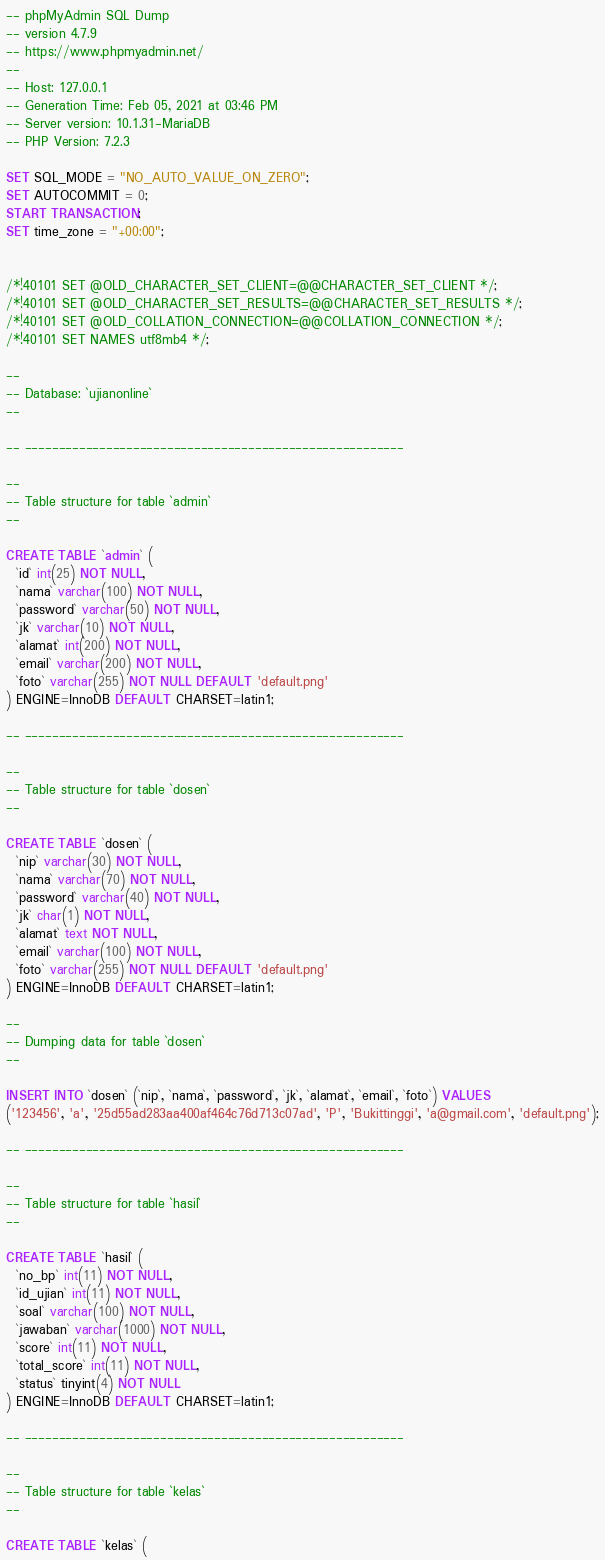Convert code to text. <code><loc_0><loc_0><loc_500><loc_500><_SQL_>-- phpMyAdmin SQL Dump
-- version 4.7.9
-- https://www.phpmyadmin.net/
--
-- Host: 127.0.0.1
-- Generation Time: Feb 05, 2021 at 03:46 PM
-- Server version: 10.1.31-MariaDB
-- PHP Version: 7.2.3

SET SQL_MODE = "NO_AUTO_VALUE_ON_ZERO";
SET AUTOCOMMIT = 0;
START TRANSACTION;
SET time_zone = "+00:00";


/*!40101 SET @OLD_CHARACTER_SET_CLIENT=@@CHARACTER_SET_CLIENT */;
/*!40101 SET @OLD_CHARACTER_SET_RESULTS=@@CHARACTER_SET_RESULTS */;
/*!40101 SET @OLD_COLLATION_CONNECTION=@@COLLATION_CONNECTION */;
/*!40101 SET NAMES utf8mb4 */;

--
-- Database: `ujianonline`
--

-- --------------------------------------------------------

--
-- Table structure for table `admin`
--

CREATE TABLE `admin` (
  `id` int(25) NOT NULL,
  `nama` varchar(100) NOT NULL,
  `password` varchar(50) NOT NULL,
  `jk` varchar(10) NOT NULL,
  `alamat` int(200) NOT NULL,
  `email` varchar(200) NOT NULL,
  `foto` varchar(255) NOT NULL DEFAULT 'default.png'
) ENGINE=InnoDB DEFAULT CHARSET=latin1;

-- --------------------------------------------------------

--
-- Table structure for table `dosen`
--

CREATE TABLE `dosen` (
  `nip` varchar(30) NOT NULL,
  `nama` varchar(70) NOT NULL,
  `password` varchar(40) NOT NULL,
  `jk` char(1) NOT NULL,
  `alamat` text NOT NULL,
  `email` varchar(100) NOT NULL,
  `foto` varchar(255) NOT NULL DEFAULT 'default.png'
) ENGINE=InnoDB DEFAULT CHARSET=latin1;

--
-- Dumping data for table `dosen`
--

INSERT INTO `dosen` (`nip`, `nama`, `password`, `jk`, `alamat`, `email`, `foto`) VALUES
('123456', 'a', '25d55ad283aa400af464c76d713c07ad', 'P', 'Bukittinggi', 'a@gmail.com', 'default.png');

-- --------------------------------------------------------

--
-- Table structure for table `hasil`
--

CREATE TABLE `hasil` (
  `no_bp` int(11) NOT NULL,
  `id_ujian` int(11) NOT NULL,
  `soal` varchar(100) NOT NULL,
  `jawaban` varchar(1000) NOT NULL,
  `score` int(11) NOT NULL,
  `total_score` int(11) NOT NULL,
  `status` tinyint(4) NOT NULL
) ENGINE=InnoDB DEFAULT CHARSET=latin1;

-- --------------------------------------------------------

--
-- Table structure for table `kelas`
--

CREATE TABLE `kelas` (</code> 